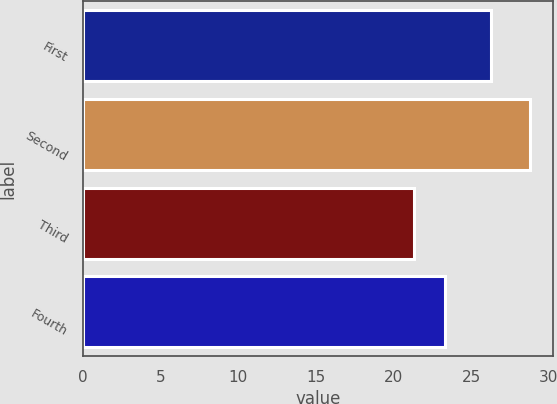Convert chart to OTSL. <chart><loc_0><loc_0><loc_500><loc_500><bar_chart><fcel>First<fcel>Second<fcel>Third<fcel>Fourth<nl><fcel>26.25<fcel>28.81<fcel>21.29<fcel>23.31<nl></chart> 